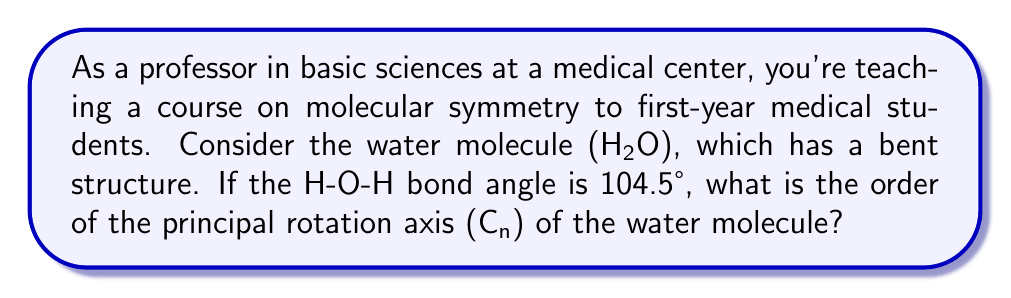Provide a solution to this math problem. To determine the order of the principal rotation axis (C_n) of the water molecule, we need to analyze its symmetry operations:

1. First, let's visualize the water molecule:

[asy]
import geometry;

pair O = (0,0);
pair H1 = (1,0);
pair H2 = cos(104.5*pi/180)+sin(104.5*pi/180)*dir(90);

draw(O--H1,blue);
draw(O--H2,blue);

dot(O,red);
dot(H1,green);
dot(H2,green);

label("O",O,SW);
label("H",H1,SE);
label("H",H2,NE);

draw(arc(O,0.5,0,104.5),dashed);
label("104.5°",0.7*dir(52.25),NW);
[/asy]

2. The principal rotation axis is the axis of highest symmetry order. For water, this is the axis that bisects the H-O-H angle.

3. The order n of a C_n axis is determined by how many times the molecule can be rotated by 360°/n to produce an identical configuration.

4. For the water molecule:
   - A 180° rotation (C_2) brings the molecule back to its original configuration.
   - No other rotation less than 360° results in an identical configuration.

5. Therefore, the highest order rotation that produces an identical configuration is 2.

This means the water molecule has a C_2 axis as its principal rotation axis.

It's worth noting that the exact H-O-H bond angle (104.5° in this case) doesn't affect the order of the principal rotation axis. The C_2 symmetry would hold true for any bent triatomic molecule with two identical terminal atoms.
Answer: The order of the principal rotation axis (C_n) of the water molecule is 2 (C_2). 